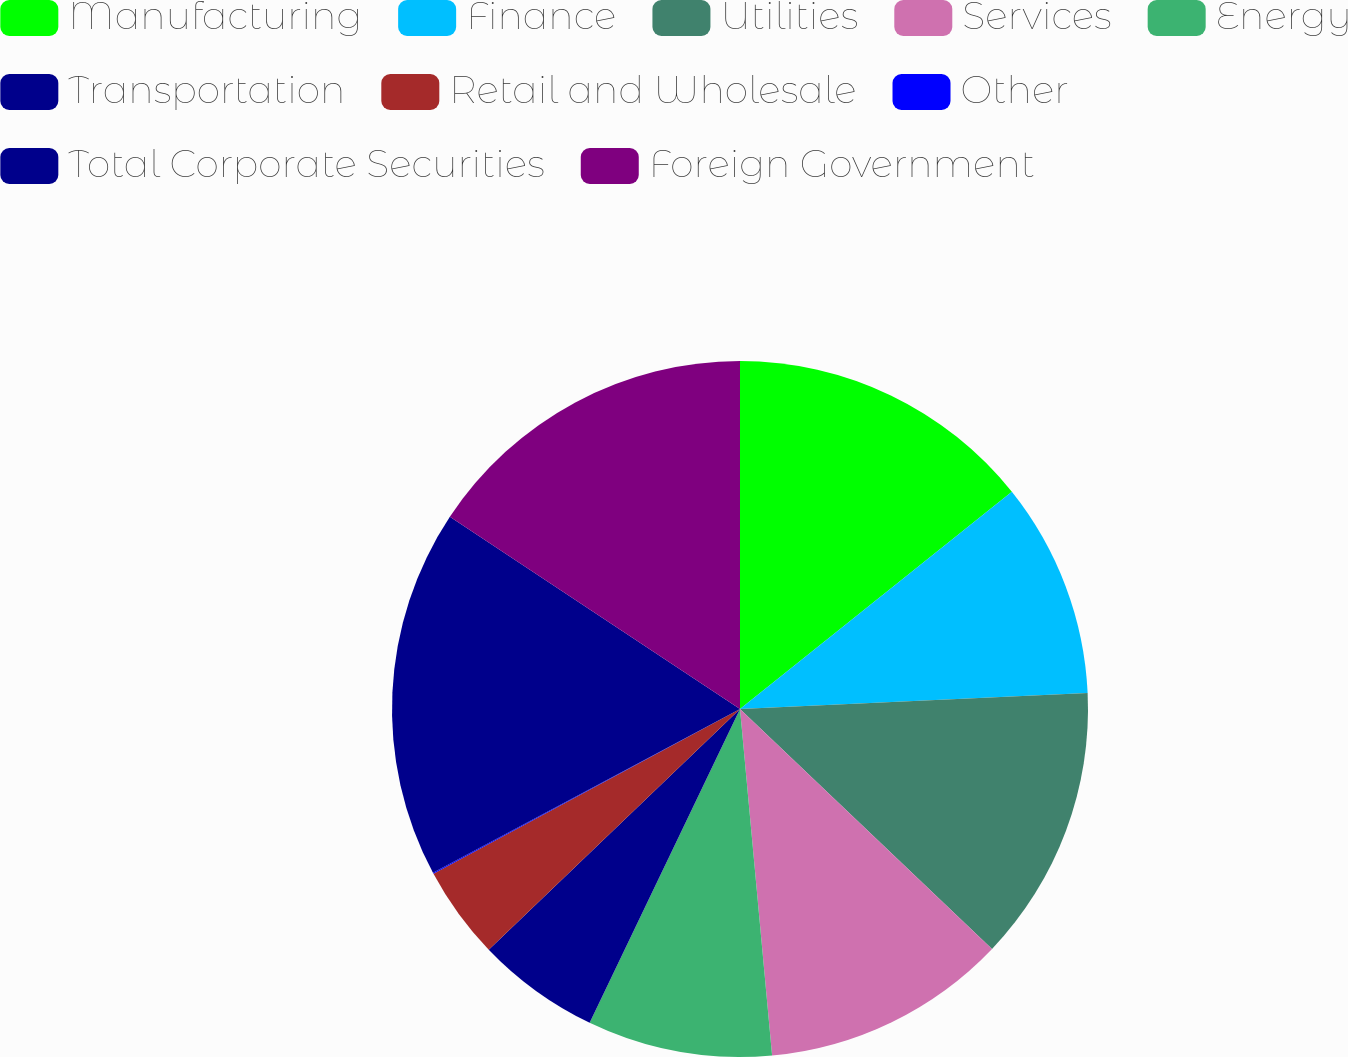Convert chart. <chart><loc_0><loc_0><loc_500><loc_500><pie_chart><fcel>Manufacturing<fcel>Finance<fcel>Utilities<fcel>Services<fcel>Energy<fcel>Transportation<fcel>Retail and Wholesale<fcel>Other<fcel>Total Corporate Securities<fcel>Foreign Government<nl><fcel>14.27%<fcel>10.0%<fcel>12.84%<fcel>11.42%<fcel>8.58%<fcel>5.73%<fcel>4.31%<fcel>0.05%<fcel>17.11%<fcel>15.69%<nl></chart> 